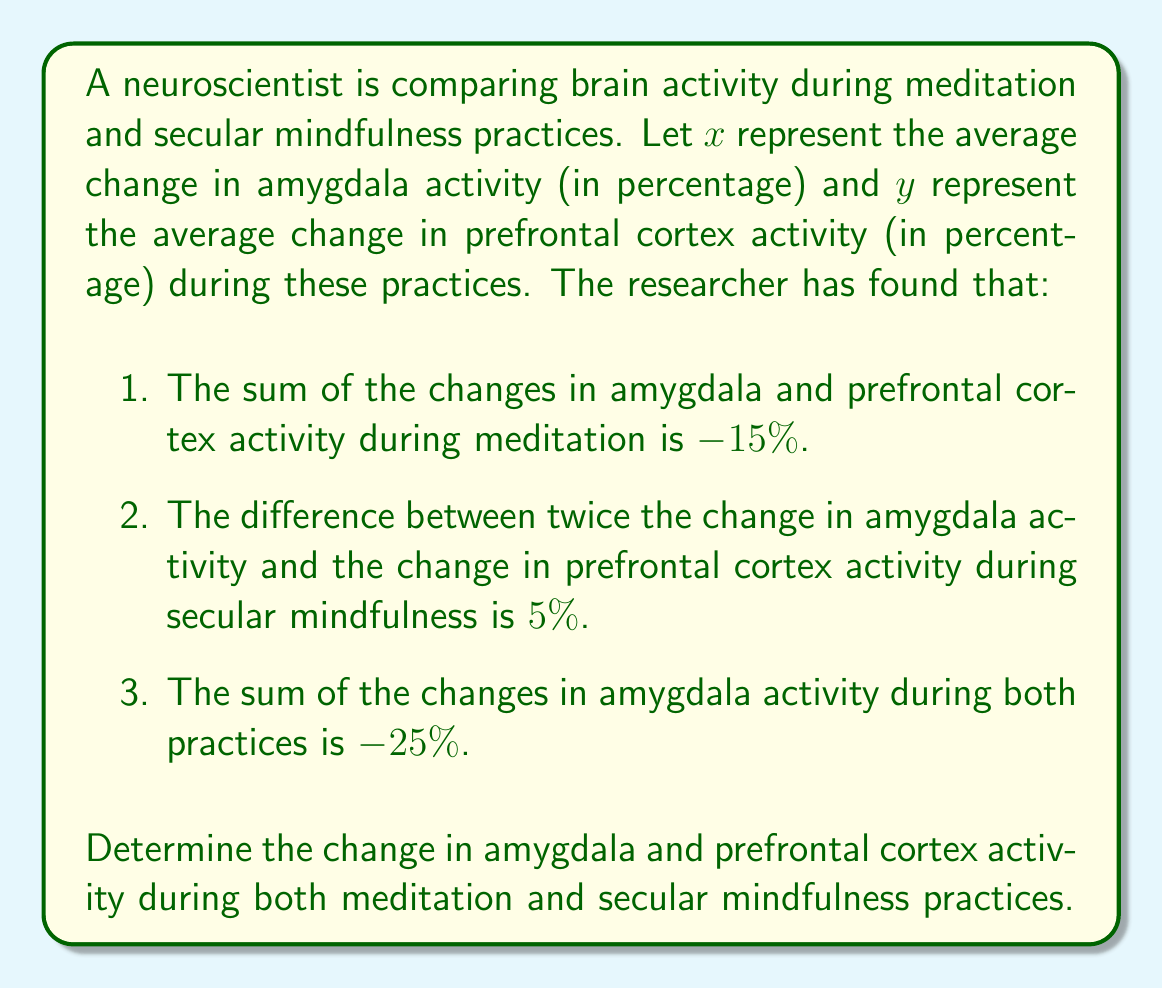Could you help me with this problem? Let's approach this problem step-by-step using a system of simultaneous equations:

1. Let's define our variables:
   $x_m$ = change in amygdala activity during meditation
   $y_m$ = change in prefrontal cortex activity during meditation
   $x_s$ = change in amygdala activity during secular mindfulness
   $y_s$ = change in prefrontal cortex activity during secular mindfulness

2. From the given information, we can form three equations:
   
   Equation 1: $x_m + y_m = -15$ (sum of changes during meditation)
   Equation 2: $2x_s - y_s = 5$ (difference during secular mindfulness)
   Equation 3: $x_m + x_s = -25$ (sum of amygdala changes in both practices)

3. From Equation 1, we can express $y_m$ in terms of $x_m$:
   $y_m = -15 - x_m$

4. Substituting this into Equation 3:
   $x_m + x_s = -25$
   $x_s = -25 - x_m$

5. Now, let's substitute this expression for $x_s$ into Equation 2:
   $2(-25 - x_m) - y_s = 5$
   $-50 - 2x_m - y_s = 5$
   $-2x_m - y_s = 55$

6. We now have a system of two equations with two unknowns:
   $x_m + y_m = -15$
   $-2x_m - y_s = 55$

7. Subtracting the first equation from the second:
   $-3x_m - y_s - y_m = 70$
   $-3x_m - (-15 - x_m) - y_s = 70$
   $-3x_m + 15 + x_m - y_s = 70$
   $-2x_m - y_s = 55$

8. This confirms our equation from step 5. Now we can solve for $x_m$:
   $x_m + y_m = -15$
   $x_m + (-15 - x_m) = -15$
   $-15 = -15$

   This is always true, so we need more information to solve for $x_m$.

9. Using Equation 3:
   $x_m + x_s = -25$
   $x_m + (-25 - x_m) = -25$
   $-25 = -25$

   Again, this is always true.

10. We can conclude that there are infinite solutions to this system. However, we can express all variables in terms of $x_m$:

    $y_m = -15 - x_m$
    $x_s = -25 - x_m$
    $y_s = -55 - 2x_m$

These equations allow us to calculate the changes for any given value of $x_m$.
Answer: The system has infinite solutions. The changes can be expressed in terms of $x_m$ (change in amygdala activity during meditation) as follows:

Meditation:
Amygdala: $x_m$
Prefrontal Cortex: $y_m = -15 - x_m$

Secular Mindfulness:
Amygdala: $x_s = -25 - x_m$
Prefrontal Cortex: $y_s = -55 - 2x_m$

Where $x_m$ can be any real number. 